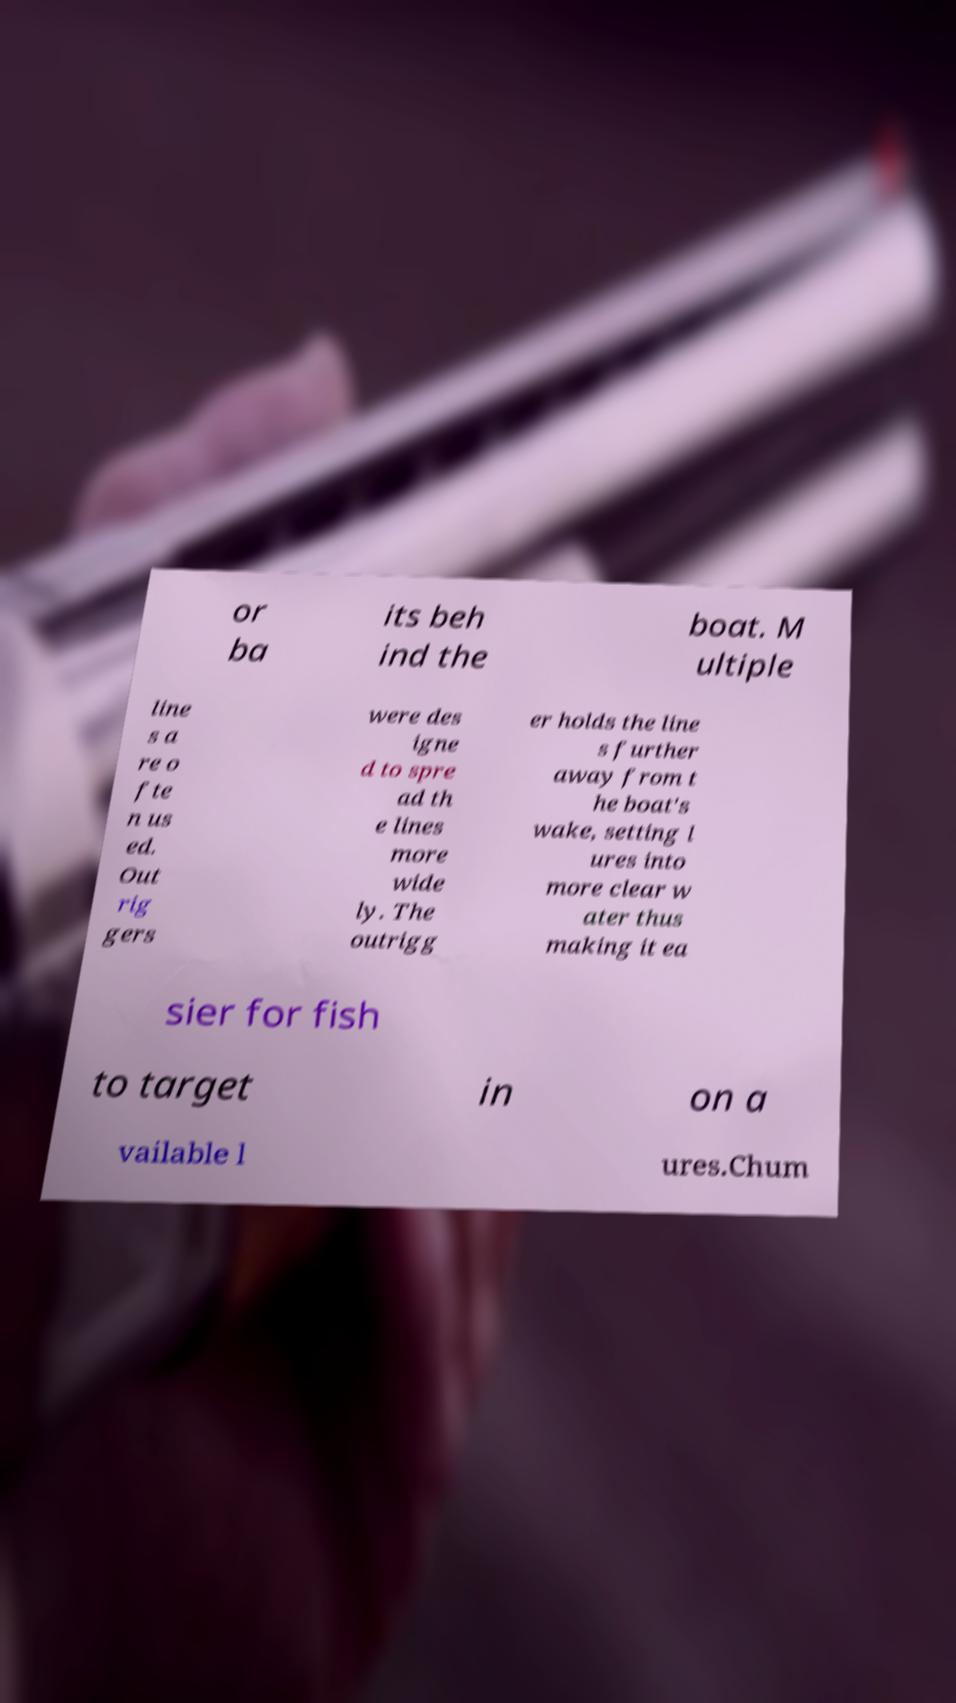For documentation purposes, I need the text within this image transcribed. Could you provide that? or ba its beh ind the boat. M ultiple line s a re o fte n us ed. Out rig gers were des igne d to spre ad th e lines more wide ly. The outrigg er holds the line s further away from t he boat's wake, setting l ures into more clear w ater thus making it ea sier for fish to target in on a vailable l ures.Chum 